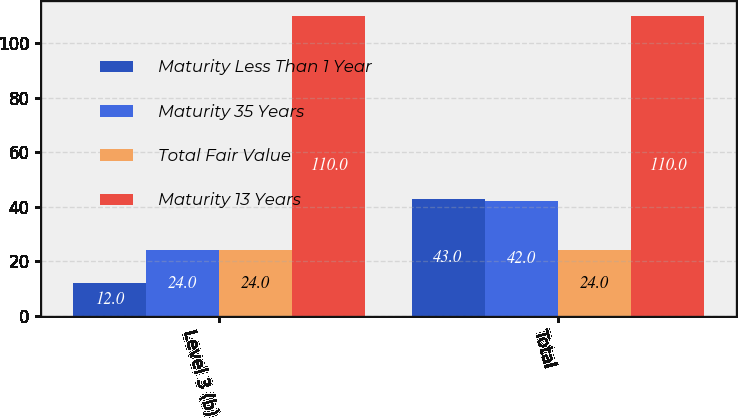Convert chart to OTSL. <chart><loc_0><loc_0><loc_500><loc_500><stacked_bar_chart><ecel><fcel>Level 3 (b)<fcel>Total<nl><fcel>Maturity Less Than 1 Year<fcel>12<fcel>43<nl><fcel>Maturity 35 Years<fcel>24<fcel>42<nl><fcel>Total Fair Value<fcel>24<fcel>24<nl><fcel>Maturity 13 Years<fcel>110<fcel>110<nl></chart> 